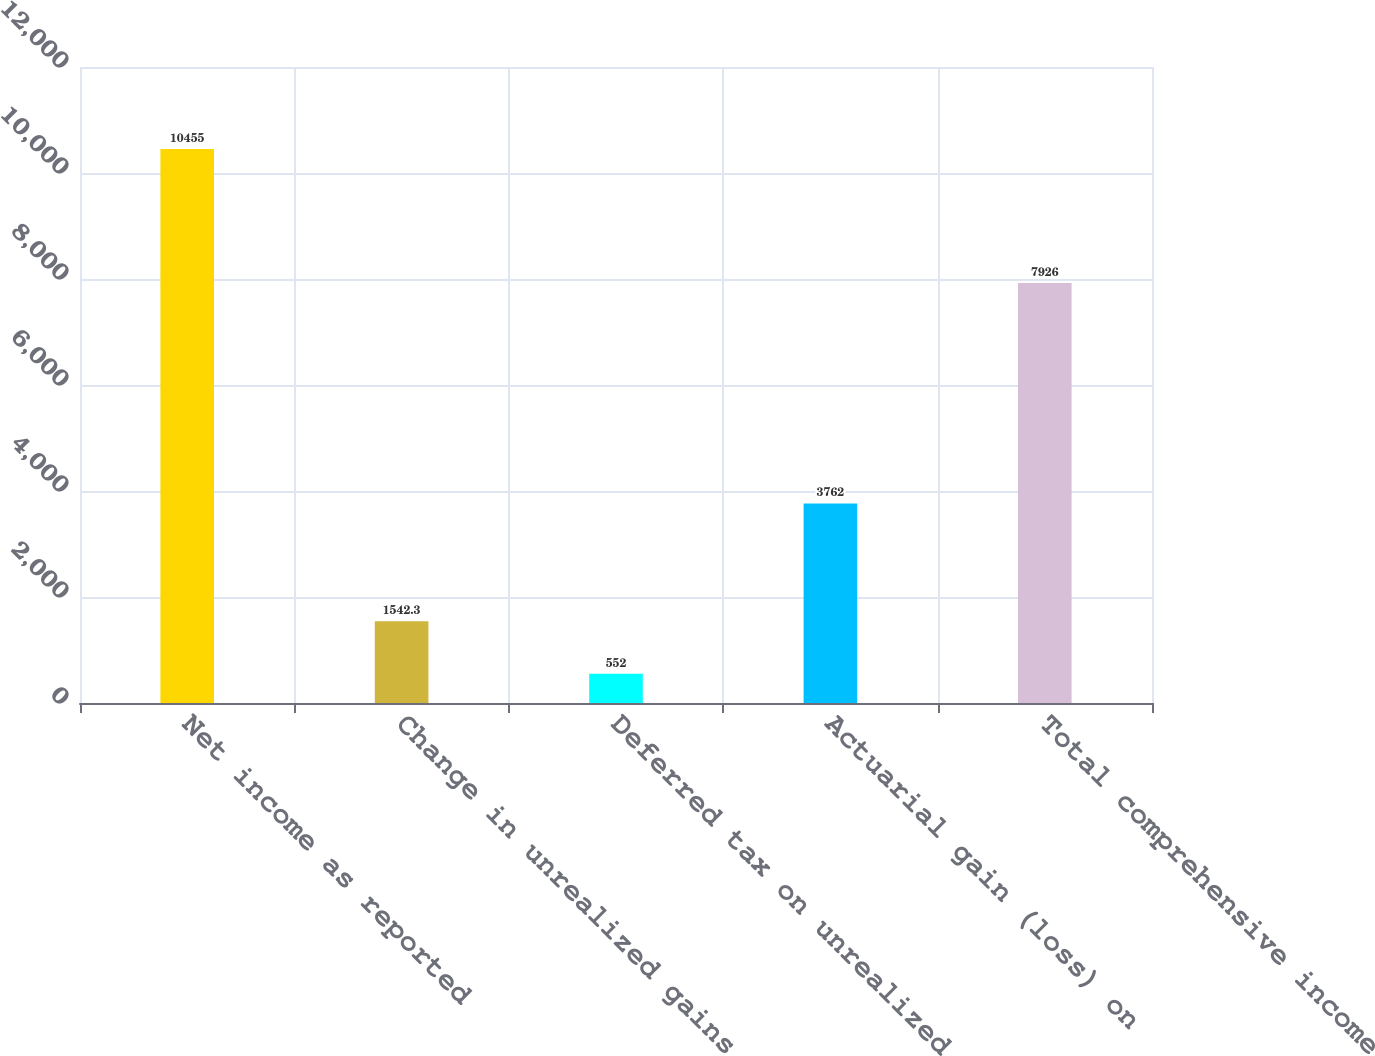Convert chart to OTSL. <chart><loc_0><loc_0><loc_500><loc_500><bar_chart><fcel>Net income as reported<fcel>Change in unrealized gains<fcel>Deferred tax on unrealized<fcel>Actuarial gain (loss) on<fcel>Total comprehensive income<nl><fcel>10455<fcel>1542.3<fcel>552<fcel>3762<fcel>7926<nl></chart> 